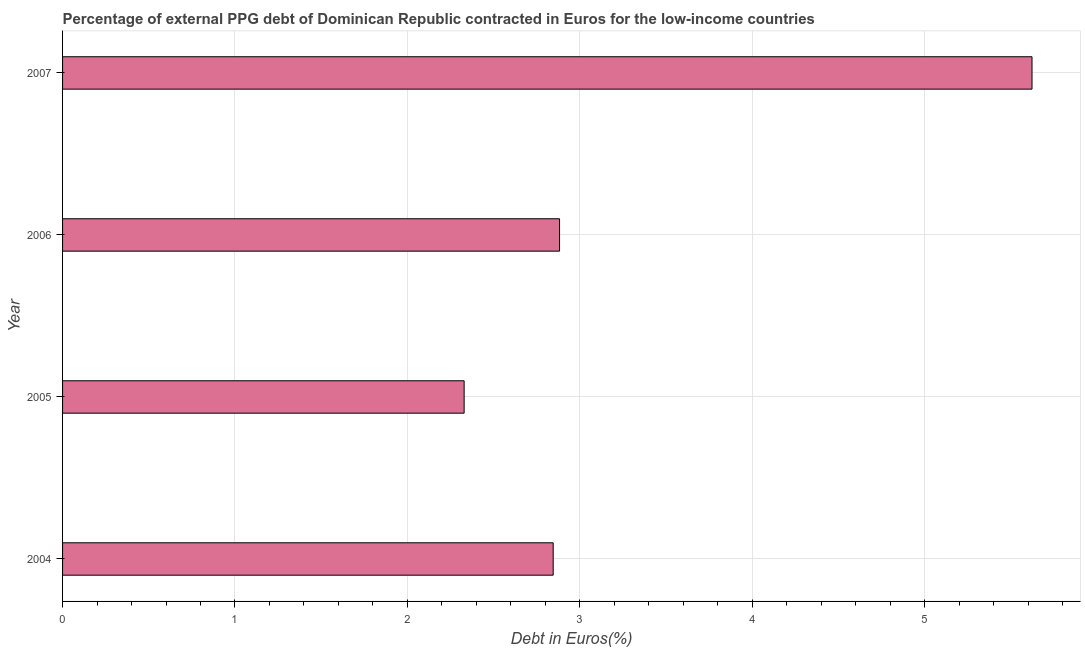What is the title of the graph?
Keep it short and to the point. Percentage of external PPG debt of Dominican Republic contracted in Euros for the low-income countries. What is the label or title of the X-axis?
Give a very brief answer. Debt in Euros(%). What is the currency composition of ppg debt in 2007?
Keep it short and to the point. 5.62. Across all years, what is the maximum currency composition of ppg debt?
Offer a very short reply. 5.62. Across all years, what is the minimum currency composition of ppg debt?
Provide a short and direct response. 2.33. In which year was the currency composition of ppg debt maximum?
Give a very brief answer. 2007. In which year was the currency composition of ppg debt minimum?
Your response must be concise. 2005. What is the sum of the currency composition of ppg debt?
Make the answer very short. 13.68. What is the difference between the currency composition of ppg debt in 2004 and 2007?
Offer a very short reply. -2.78. What is the average currency composition of ppg debt per year?
Keep it short and to the point. 3.42. What is the median currency composition of ppg debt?
Your answer should be very brief. 2.86. In how many years, is the currency composition of ppg debt greater than 0.4 %?
Make the answer very short. 4. Do a majority of the years between 2007 and 2005 (inclusive) have currency composition of ppg debt greater than 1.8 %?
Your answer should be very brief. Yes. What is the ratio of the currency composition of ppg debt in 2004 to that in 2007?
Offer a very short reply. 0.51. Is the currency composition of ppg debt in 2005 less than that in 2007?
Offer a terse response. Yes. What is the difference between the highest and the second highest currency composition of ppg debt?
Provide a short and direct response. 2.74. Is the sum of the currency composition of ppg debt in 2004 and 2006 greater than the maximum currency composition of ppg debt across all years?
Offer a very short reply. Yes. What is the difference between the highest and the lowest currency composition of ppg debt?
Your answer should be very brief. 3.29. How many years are there in the graph?
Your response must be concise. 4. What is the difference between two consecutive major ticks on the X-axis?
Your answer should be compact. 1. What is the Debt in Euros(%) of 2004?
Your answer should be compact. 2.85. What is the Debt in Euros(%) of 2005?
Your answer should be very brief. 2.33. What is the Debt in Euros(%) of 2006?
Give a very brief answer. 2.88. What is the Debt in Euros(%) of 2007?
Your answer should be very brief. 5.62. What is the difference between the Debt in Euros(%) in 2004 and 2005?
Offer a very short reply. 0.52. What is the difference between the Debt in Euros(%) in 2004 and 2006?
Keep it short and to the point. -0.04. What is the difference between the Debt in Euros(%) in 2004 and 2007?
Ensure brevity in your answer.  -2.78. What is the difference between the Debt in Euros(%) in 2005 and 2006?
Offer a terse response. -0.55. What is the difference between the Debt in Euros(%) in 2005 and 2007?
Offer a very short reply. -3.29. What is the difference between the Debt in Euros(%) in 2006 and 2007?
Make the answer very short. -2.74. What is the ratio of the Debt in Euros(%) in 2004 to that in 2005?
Provide a succinct answer. 1.22. What is the ratio of the Debt in Euros(%) in 2004 to that in 2006?
Provide a succinct answer. 0.99. What is the ratio of the Debt in Euros(%) in 2004 to that in 2007?
Your response must be concise. 0.51. What is the ratio of the Debt in Euros(%) in 2005 to that in 2006?
Keep it short and to the point. 0.81. What is the ratio of the Debt in Euros(%) in 2005 to that in 2007?
Your response must be concise. 0.41. What is the ratio of the Debt in Euros(%) in 2006 to that in 2007?
Provide a succinct answer. 0.51. 